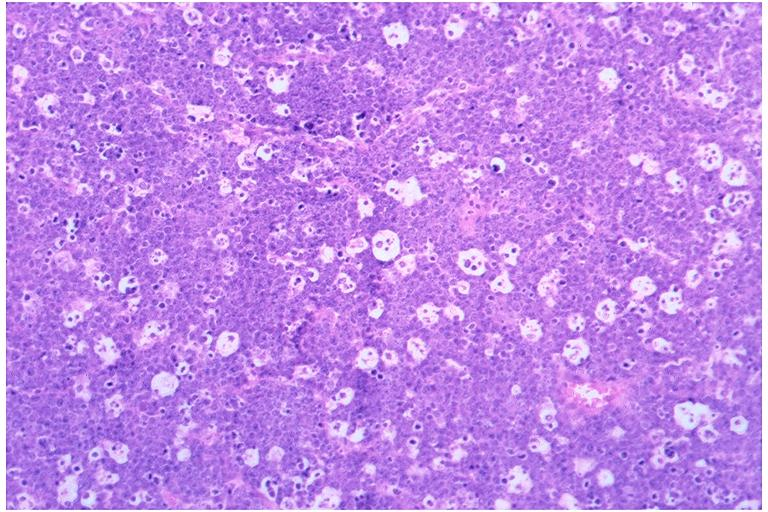where is this?
Answer the question using a single word or phrase. Oral 